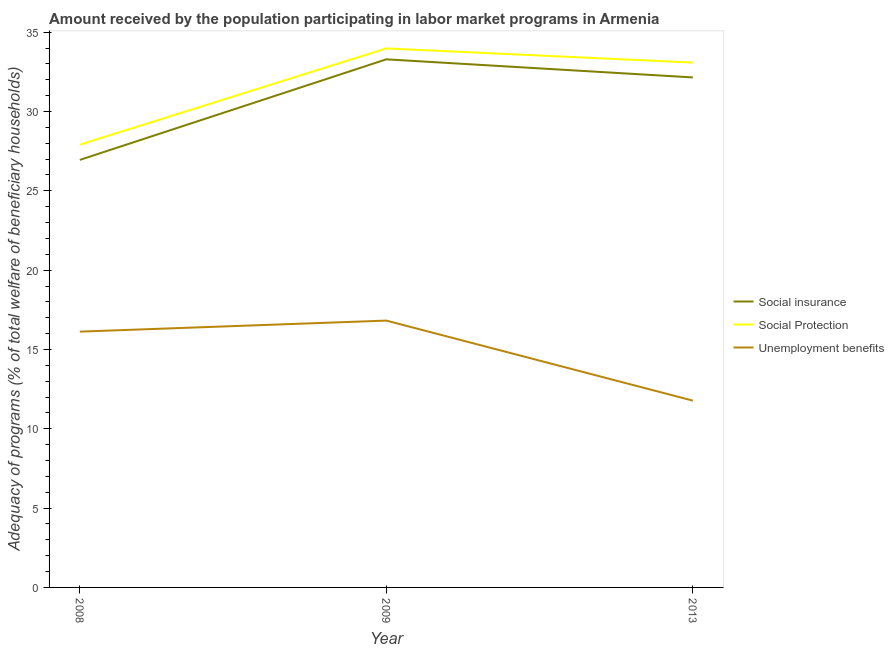Is the number of lines equal to the number of legend labels?
Ensure brevity in your answer.  Yes. What is the amount received by the population participating in social protection programs in 2008?
Keep it short and to the point. 27.91. Across all years, what is the maximum amount received by the population participating in social protection programs?
Offer a terse response. 33.98. Across all years, what is the minimum amount received by the population participating in social protection programs?
Your answer should be very brief. 27.91. In which year was the amount received by the population participating in social insurance programs maximum?
Your answer should be compact. 2009. What is the total amount received by the population participating in social insurance programs in the graph?
Your response must be concise. 92.39. What is the difference between the amount received by the population participating in social insurance programs in 2008 and that in 2013?
Offer a very short reply. -5.2. What is the difference between the amount received by the population participating in social protection programs in 2008 and the amount received by the population participating in social insurance programs in 2009?
Keep it short and to the point. -5.38. What is the average amount received by the population participating in social protection programs per year?
Your response must be concise. 31.66. In the year 2009, what is the difference between the amount received by the population participating in social protection programs and amount received by the population participating in unemployment benefits programs?
Ensure brevity in your answer.  17.16. What is the ratio of the amount received by the population participating in unemployment benefits programs in 2008 to that in 2009?
Provide a short and direct response. 0.96. Is the amount received by the population participating in social insurance programs in 2008 less than that in 2013?
Offer a very short reply. Yes. What is the difference between the highest and the second highest amount received by the population participating in unemployment benefits programs?
Keep it short and to the point. 0.7. What is the difference between the highest and the lowest amount received by the population participating in social protection programs?
Keep it short and to the point. 6.07. Is it the case that in every year, the sum of the amount received by the population participating in social insurance programs and amount received by the population participating in social protection programs is greater than the amount received by the population participating in unemployment benefits programs?
Give a very brief answer. Yes. Does the amount received by the population participating in social insurance programs monotonically increase over the years?
Give a very brief answer. No. How many years are there in the graph?
Your answer should be compact. 3. Does the graph contain any zero values?
Make the answer very short. No. Does the graph contain grids?
Keep it short and to the point. No. Where does the legend appear in the graph?
Ensure brevity in your answer.  Center right. How many legend labels are there?
Give a very brief answer. 3. What is the title of the graph?
Provide a short and direct response. Amount received by the population participating in labor market programs in Armenia. What is the label or title of the X-axis?
Keep it short and to the point. Year. What is the label or title of the Y-axis?
Your answer should be compact. Adequacy of programs (% of total welfare of beneficiary households). What is the Adequacy of programs (% of total welfare of beneficiary households) in Social insurance in 2008?
Your response must be concise. 26.95. What is the Adequacy of programs (% of total welfare of beneficiary households) of Social Protection in 2008?
Your answer should be very brief. 27.91. What is the Adequacy of programs (% of total welfare of beneficiary households) of Unemployment benefits in 2008?
Offer a very short reply. 16.12. What is the Adequacy of programs (% of total welfare of beneficiary households) in Social insurance in 2009?
Provide a succinct answer. 33.29. What is the Adequacy of programs (% of total welfare of beneficiary households) of Social Protection in 2009?
Your answer should be compact. 33.98. What is the Adequacy of programs (% of total welfare of beneficiary households) of Unemployment benefits in 2009?
Make the answer very short. 16.82. What is the Adequacy of programs (% of total welfare of beneficiary households) in Social insurance in 2013?
Keep it short and to the point. 32.15. What is the Adequacy of programs (% of total welfare of beneficiary households) in Social Protection in 2013?
Your answer should be compact. 33.08. What is the Adequacy of programs (% of total welfare of beneficiary households) in Unemployment benefits in 2013?
Give a very brief answer. 11.77. Across all years, what is the maximum Adequacy of programs (% of total welfare of beneficiary households) of Social insurance?
Keep it short and to the point. 33.29. Across all years, what is the maximum Adequacy of programs (% of total welfare of beneficiary households) of Social Protection?
Your answer should be compact. 33.98. Across all years, what is the maximum Adequacy of programs (% of total welfare of beneficiary households) in Unemployment benefits?
Your answer should be very brief. 16.82. Across all years, what is the minimum Adequacy of programs (% of total welfare of beneficiary households) of Social insurance?
Ensure brevity in your answer.  26.95. Across all years, what is the minimum Adequacy of programs (% of total welfare of beneficiary households) of Social Protection?
Keep it short and to the point. 27.91. Across all years, what is the minimum Adequacy of programs (% of total welfare of beneficiary households) in Unemployment benefits?
Your answer should be very brief. 11.77. What is the total Adequacy of programs (% of total welfare of beneficiary households) of Social insurance in the graph?
Your answer should be compact. 92.39. What is the total Adequacy of programs (% of total welfare of beneficiary households) of Social Protection in the graph?
Keep it short and to the point. 94.97. What is the total Adequacy of programs (% of total welfare of beneficiary households) in Unemployment benefits in the graph?
Your answer should be compact. 44.72. What is the difference between the Adequacy of programs (% of total welfare of beneficiary households) in Social insurance in 2008 and that in 2009?
Ensure brevity in your answer.  -6.34. What is the difference between the Adequacy of programs (% of total welfare of beneficiary households) in Social Protection in 2008 and that in 2009?
Offer a terse response. -6.07. What is the difference between the Adequacy of programs (% of total welfare of beneficiary households) in Unemployment benefits in 2008 and that in 2009?
Your answer should be very brief. -0.7. What is the difference between the Adequacy of programs (% of total welfare of beneficiary households) in Social insurance in 2008 and that in 2013?
Offer a very short reply. -5.2. What is the difference between the Adequacy of programs (% of total welfare of beneficiary households) in Social Protection in 2008 and that in 2013?
Your answer should be compact. -5.18. What is the difference between the Adequacy of programs (% of total welfare of beneficiary households) in Unemployment benefits in 2008 and that in 2013?
Keep it short and to the point. 4.35. What is the difference between the Adequacy of programs (% of total welfare of beneficiary households) of Social insurance in 2009 and that in 2013?
Your answer should be compact. 1.14. What is the difference between the Adequacy of programs (% of total welfare of beneficiary households) in Social Protection in 2009 and that in 2013?
Offer a terse response. 0.89. What is the difference between the Adequacy of programs (% of total welfare of beneficiary households) of Unemployment benefits in 2009 and that in 2013?
Ensure brevity in your answer.  5.05. What is the difference between the Adequacy of programs (% of total welfare of beneficiary households) in Social insurance in 2008 and the Adequacy of programs (% of total welfare of beneficiary households) in Social Protection in 2009?
Keep it short and to the point. -7.03. What is the difference between the Adequacy of programs (% of total welfare of beneficiary households) of Social insurance in 2008 and the Adequacy of programs (% of total welfare of beneficiary households) of Unemployment benefits in 2009?
Give a very brief answer. 10.13. What is the difference between the Adequacy of programs (% of total welfare of beneficiary households) of Social Protection in 2008 and the Adequacy of programs (% of total welfare of beneficiary households) of Unemployment benefits in 2009?
Give a very brief answer. 11.09. What is the difference between the Adequacy of programs (% of total welfare of beneficiary households) in Social insurance in 2008 and the Adequacy of programs (% of total welfare of beneficiary households) in Social Protection in 2013?
Keep it short and to the point. -6.14. What is the difference between the Adequacy of programs (% of total welfare of beneficiary households) in Social insurance in 2008 and the Adequacy of programs (% of total welfare of beneficiary households) in Unemployment benefits in 2013?
Keep it short and to the point. 15.17. What is the difference between the Adequacy of programs (% of total welfare of beneficiary households) in Social Protection in 2008 and the Adequacy of programs (% of total welfare of beneficiary households) in Unemployment benefits in 2013?
Offer a very short reply. 16.13. What is the difference between the Adequacy of programs (% of total welfare of beneficiary households) of Social insurance in 2009 and the Adequacy of programs (% of total welfare of beneficiary households) of Social Protection in 2013?
Offer a very short reply. 0.21. What is the difference between the Adequacy of programs (% of total welfare of beneficiary households) in Social insurance in 2009 and the Adequacy of programs (% of total welfare of beneficiary households) in Unemployment benefits in 2013?
Keep it short and to the point. 21.52. What is the difference between the Adequacy of programs (% of total welfare of beneficiary households) of Social Protection in 2009 and the Adequacy of programs (% of total welfare of beneficiary households) of Unemployment benefits in 2013?
Provide a succinct answer. 22.2. What is the average Adequacy of programs (% of total welfare of beneficiary households) of Social insurance per year?
Ensure brevity in your answer.  30.8. What is the average Adequacy of programs (% of total welfare of beneficiary households) in Social Protection per year?
Keep it short and to the point. 31.66. What is the average Adequacy of programs (% of total welfare of beneficiary households) of Unemployment benefits per year?
Provide a short and direct response. 14.91. In the year 2008, what is the difference between the Adequacy of programs (% of total welfare of beneficiary households) in Social insurance and Adequacy of programs (% of total welfare of beneficiary households) in Social Protection?
Ensure brevity in your answer.  -0.96. In the year 2008, what is the difference between the Adequacy of programs (% of total welfare of beneficiary households) of Social insurance and Adequacy of programs (% of total welfare of beneficiary households) of Unemployment benefits?
Keep it short and to the point. 10.82. In the year 2008, what is the difference between the Adequacy of programs (% of total welfare of beneficiary households) of Social Protection and Adequacy of programs (% of total welfare of beneficiary households) of Unemployment benefits?
Offer a very short reply. 11.78. In the year 2009, what is the difference between the Adequacy of programs (% of total welfare of beneficiary households) of Social insurance and Adequacy of programs (% of total welfare of beneficiary households) of Social Protection?
Your response must be concise. -0.69. In the year 2009, what is the difference between the Adequacy of programs (% of total welfare of beneficiary households) in Social insurance and Adequacy of programs (% of total welfare of beneficiary households) in Unemployment benefits?
Make the answer very short. 16.47. In the year 2009, what is the difference between the Adequacy of programs (% of total welfare of beneficiary households) of Social Protection and Adequacy of programs (% of total welfare of beneficiary households) of Unemployment benefits?
Provide a succinct answer. 17.16. In the year 2013, what is the difference between the Adequacy of programs (% of total welfare of beneficiary households) of Social insurance and Adequacy of programs (% of total welfare of beneficiary households) of Social Protection?
Make the answer very short. -0.94. In the year 2013, what is the difference between the Adequacy of programs (% of total welfare of beneficiary households) in Social insurance and Adequacy of programs (% of total welfare of beneficiary households) in Unemployment benefits?
Keep it short and to the point. 20.37. In the year 2013, what is the difference between the Adequacy of programs (% of total welfare of beneficiary households) of Social Protection and Adequacy of programs (% of total welfare of beneficiary households) of Unemployment benefits?
Your answer should be very brief. 21.31. What is the ratio of the Adequacy of programs (% of total welfare of beneficiary households) of Social insurance in 2008 to that in 2009?
Your answer should be compact. 0.81. What is the ratio of the Adequacy of programs (% of total welfare of beneficiary households) of Social Protection in 2008 to that in 2009?
Provide a short and direct response. 0.82. What is the ratio of the Adequacy of programs (% of total welfare of beneficiary households) of Unemployment benefits in 2008 to that in 2009?
Your answer should be compact. 0.96. What is the ratio of the Adequacy of programs (% of total welfare of beneficiary households) of Social insurance in 2008 to that in 2013?
Make the answer very short. 0.84. What is the ratio of the Adequacy of programs (% of total welfare of beneficiary households) of Social Protection in 2008 to that in 2013?
Provide a succinct answer. 0.84. What is the ratio of the Adequacy of programs (% of total welfare of beneficiary households) in Unemployment benefits in 2008 to that in 2013?
Ensure brevity in your answer.  1.37. What is the ratio of the Adequacy of programs (% of total welfare of beneficiary households) in Social insurance in 2009 to that in 2013?
Ensure brevity in your answer.  1.04. What is the ratio of the Adequacy of programs (% of total welfare of beneficiary households) of Unemployment benefits in 2009 to that in 2013?
Make the answer very short. 1.43. What is the difference between the highest and the second highest Adequacy of programs (% of total welfare of beneficiary households) in Social insurance?
Provide a succinct answer. 1.14. What is the difference between the highest and the second highest Adequacy of programs (% of total welfare of beneficiary households) of Social Protection?
Your answer should be compact. 0.89. What is the difference between the highest and the second highest Adequacy of programs (% of total welfare of beneficiary households) in Unemployment benefits?
Provide a short and direct response. 0.7. What is the difference between the highest and the lowest Adequacy of programs (% of total welfare of beneficiary households) in Social insurance?
Make the answer very short. 6.34. What is the difference between the highest and the lowest Adequacy of programs (% of total welfare of beneficiary households) in Social Protection?
Your answer should be very brief. 6.07. What is the difference between the highest and the lowest Adequacy of programs (% of total welfare of beneficiary households) in Unemployment benefits?
Provide a succinct answer. 5.05. 